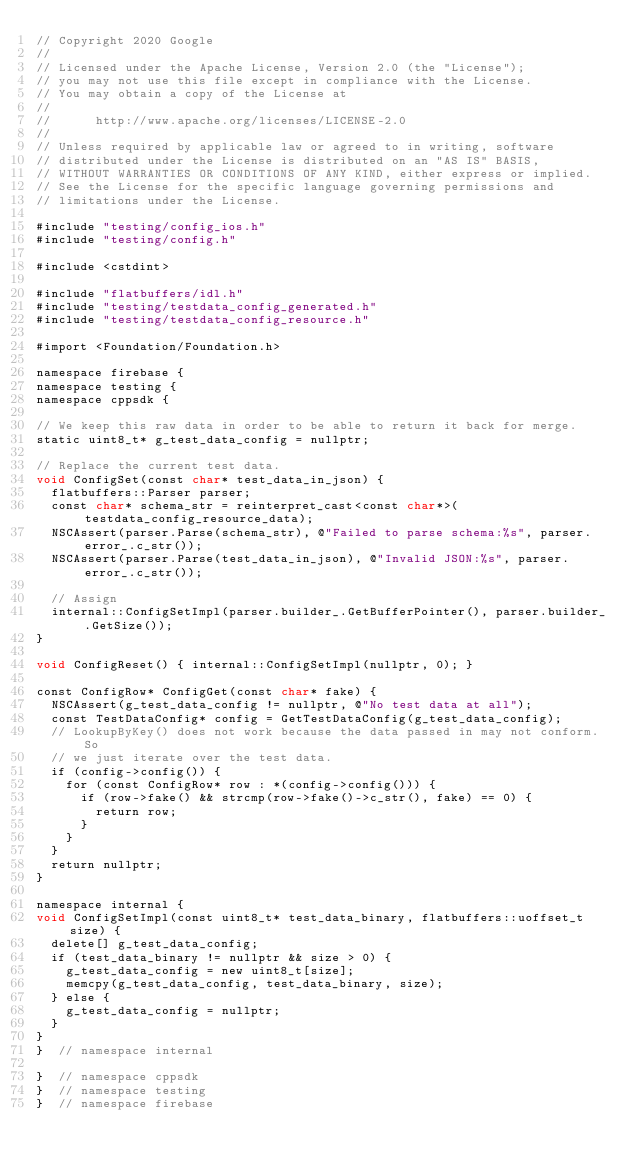Convert code to text. <code><loc_0><loc_0><loc_500><loc_500><_ObjectiveC_>// Copyright 2020 Google
//
// Licensed under the Apache License, Version 2.0 (the "License");
// you may not use this file except in compliance with the License.
// You may obtain a copy of the License at
//
//      http://www.apache.org/licenses/LICENSE-2.0
//
// Unless required by applicable law or agreed to in writing, software
// distributed under the License is distributed on an "AS IS" BASIS,
// WITHOUT WARRANTIES OR CONDITIONS OF ANY KIND, either express or implied.
// See the License for the specific language governing permissions and
// limitations under the License.

#include "testing/config_ios.h"
#include "testing/config.h"

#include <cstdint>

#include "flatbuffers/idl.h"
#include "testing/testdata_config_generated.h"
#include "testing/testdata_config_resource.h"

#import <Foundation/Foundation.h>

namespace firebase {
namespace testing {
namespace cppsdk {

// We keep this raw data in order to be able to return it back for merge.
static uint8_t* g_test_data_config = nullptr;

// Replace the current test data.
void ConfigSet(const char* test_data_in_json) {
  flatbuffers::Parser parser;
  const char* schema_str = reinterpret_cast<const char*>(testdata_config_resource_data);
  NSCAssert(parser.Parse(schema_str), @"Failed to parse schema:%s", parser.error_.c_str());
  NSCAssert(parser.Parse(test_data_in_json), @"Invalid JSON:%s", parser.error_.c_str());

  // Assign
  internal::ConfigSetImpl(parser.builder_.GetBufferPointer(), parser.builder_.GetSize());
}

void ConfigReset() { internal::ConfigSetImpl(nullptr, 0); }

const ConfigRow* ConfigGet(const char* fake) {
  NSCAssert(g_test_data_config != nullptr, @"No test data at all");
  const TestDataConfig* config = GetTestDataConfig(g_test_data_config);
  // LookupByKey() does not work because the data passed in may not conform. So
  // we just iterate over the test data.
  if (config->config()) {
    for (const ConfigRow* row : *(config->config())) {
      if (row->fake() && strcmp(row->fake()->c_str(), fake) == 0) {
        return row;
      }
    }
  }
  return nullptr;
}

namespace internal {
void ConfigSetImpl(const uint8_t* test_data_binary, flatbuffers::uoffset_t size) {
  delete[] g_test_data_config;
  if (test_data_binary != nullptr && size > 0) {
    g_test_data_config = new uint8_t[size];
    memcpy(g_test_data_config, test_data_binary, size);
  } else {
    g_test_data_config = nullptr;
  }
}
}  // namespace internal

}  // namespace cppsdk
}  // namespace testing
}  // namespace firebase
</code> 